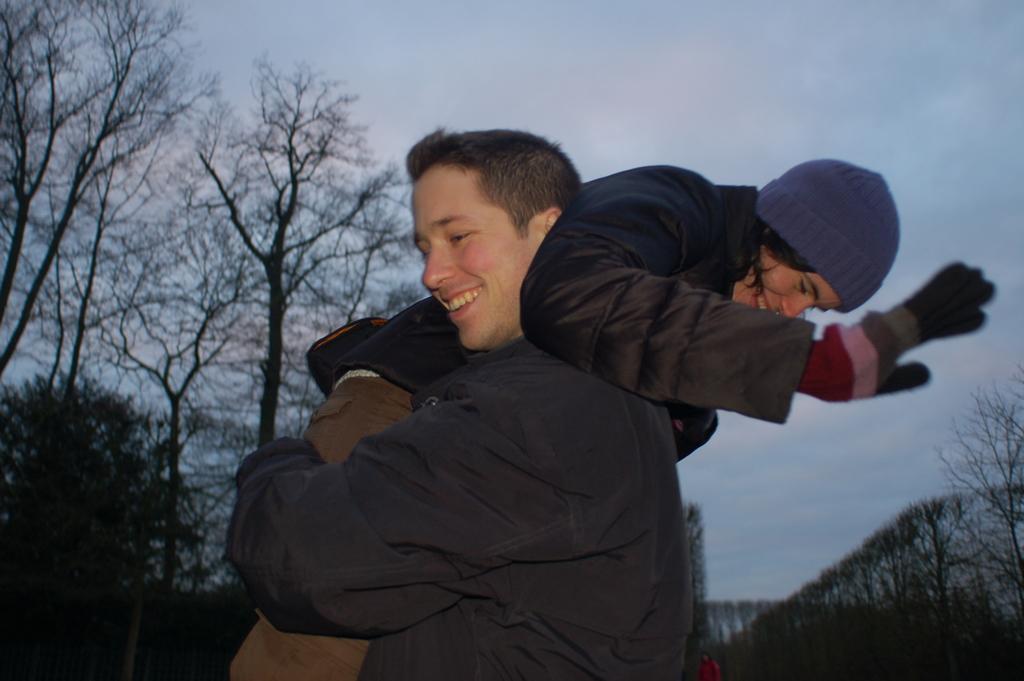Describe this image in one or two sentences. There is a person holding another person wearing cap and gloves. In the background there are trees and sky. 